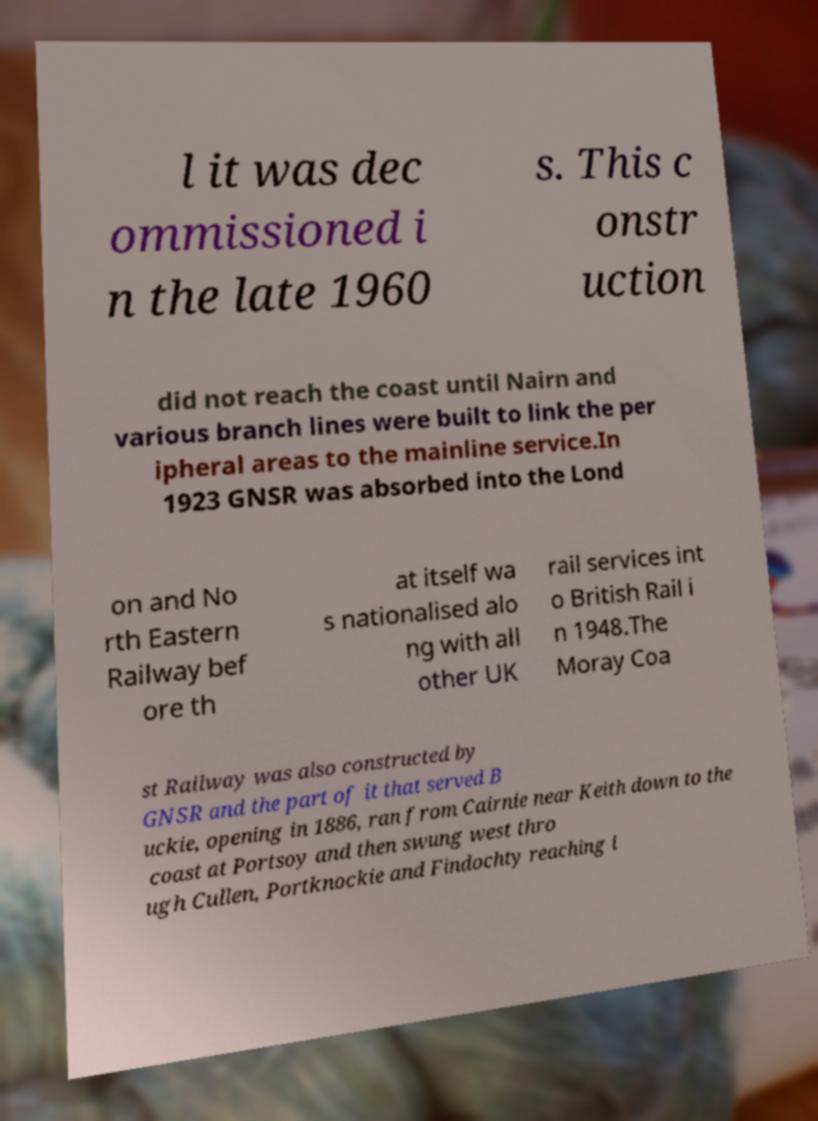There's text embedded in this image that I need extracted. Can you transcribe it verbatim? l it was dec ommissioned i n the late 1960 s. This c onstr uction did not reach the coast until Nairn and various branch lines were built to link the per ipheral areas to the mainline service.In 1923 GNSR was absorbed into the Lond on and No rth Eastern Railway bef ore th at itself wa s nationalised alo ng with all other UK rail services int o British Rail i n 1948.The Moray Coa st Railway was also constructed by GNSR and the part of it that served B uckie, opening in 1886, ran from Cairnie near Keith down to the coast at Portsoy and then swung west thro ugh Cullen, Portknockie and Findochty reaching i 